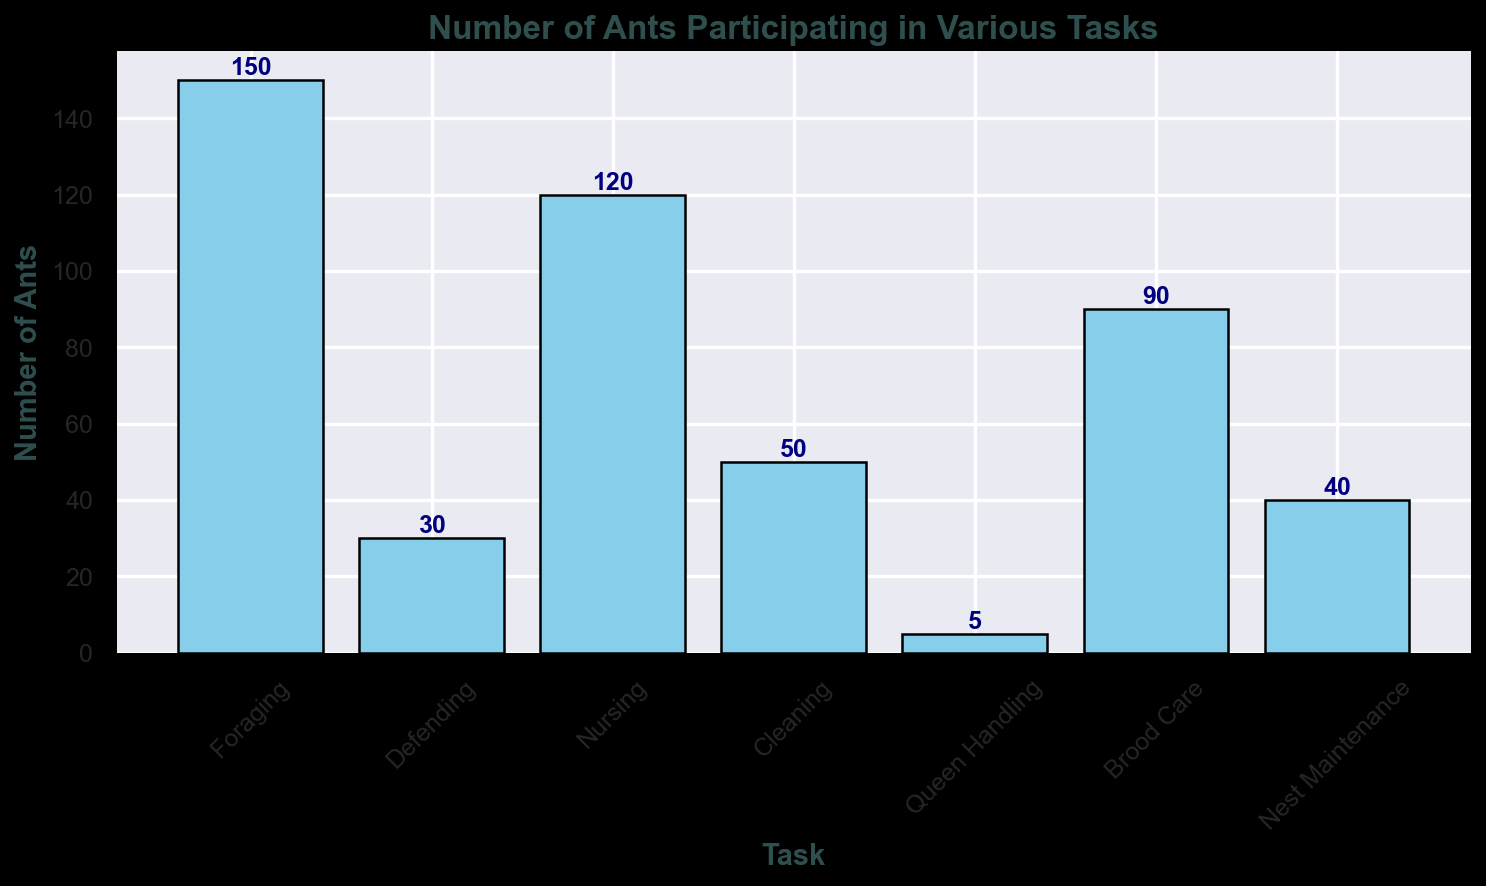Which task has the highest number of ants? Look at the bar heights in the chart, the tallest bar corresponds to the task with the highest number of ants. The "Foraging" task has the tallest bar.
Answer: Foraging Which task has the fewest ants? Observe the bar heights. The shortest bar corresponds to the task with the fewest ants. "Queen Handling" has the shortest bar.
Answer: Queen Handling How many more ants are foraging compared to defending? Find the heights of the bars for "Foraging" and "Defending". Foraging has 150 ants and Defending has 30 ants. Subtract the number of ants in Defending from Foraging (150 - 30).
Answer: 120 What's the average number of ants across all tasks? Add the number of ants for each task, then divide by the total number of tasks. Sum: 150 + 30 + 120 + 50 + 5 + 90 + 40 = 485. Number of tasks = 7. Average = 485 / 7.
Answer: 69.29 How many more ants are there in Nursing compared to Brood Care and Queen Handling combined? Find the number of ants in "Nursing" and in "Brood Care" and "Queen Handling". Nursing = 120, Brood Care = 90, Queen Handling = 5. Sum Brood Care and Queen Handling (90 + 5 = 95), then subtract from Nursing (120 - 95).
Answer: 25 Is Nest Maintenance more popular than Cleaning among the ants? Compare the bar heights for "Nest Maintenance" and "Cleaning". "Cleaning" has a taller bar with 50 ants, while "Nest Maintenance" has 40 ants.
Answer: No Which tasks have fewer than 50 ants? Identify the bars whose height represents fewer than 50 ants. "Defending" and "Queen Handling" tasks both have fewer than 50 ants.
Answer: Defending, Queen Handling What's the total number of ants involved in tasks related to care (Nursing, Brood Care)? Sum the number of ants in "Nursing" and "Brood Care". Nursing = 120, Brood Care = 90. Sum = 120 + 90.
Answer: 210 Which tasks have more than 100 ants? Identify the bars whose height represents more than 100 ants. "Foraging" and "Nursing" both have more than 100 ants.
Answer: Foraging, Nursing 